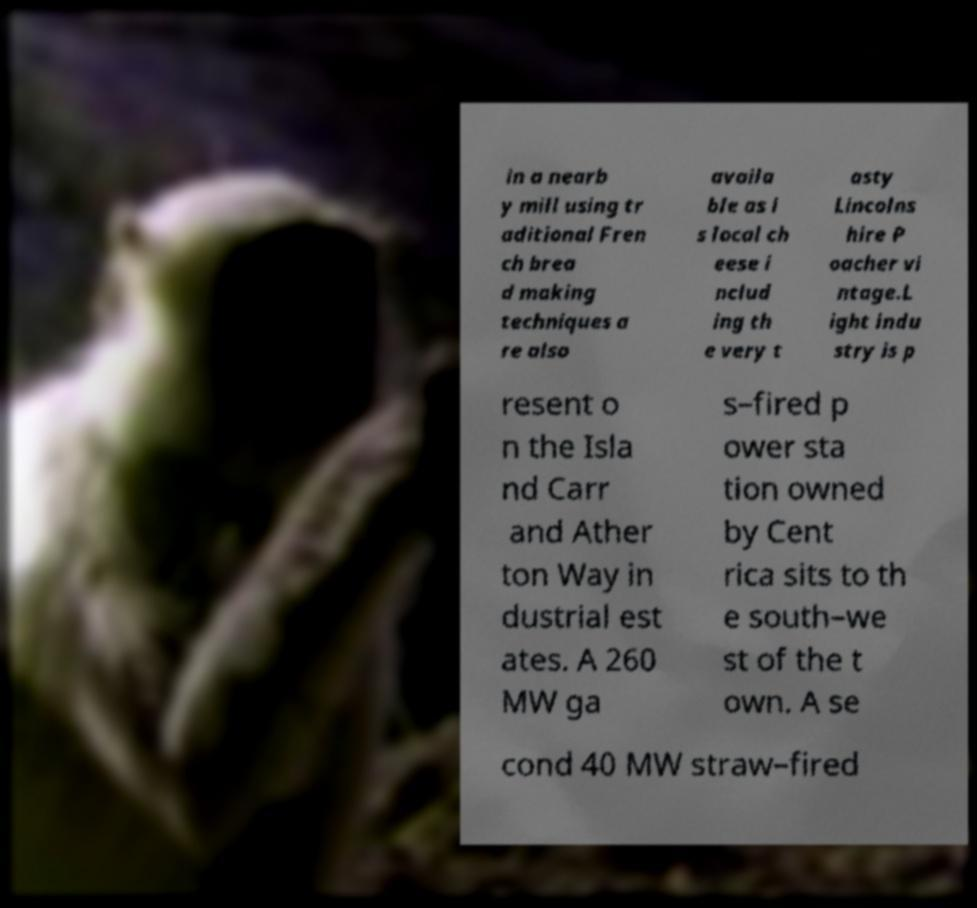There's text embedded in this image that I need extracted. Can you transcribe it verbatim? in a nearb y mill using tr aditional Fren ch brea d making techniques a re also availa ble as i s local ch eese i nclud ing th e very t asty Lincolns hire P oacher vi ntage.L ight indu stry is p resent o n the Isla nd Carr and Ather ton Way in dustrial est ates. A 260 MW ga s–fired p ower sta tion owned by Cent rica sits to th e south–we st of the t own. A se cond 40 MW straw–fired 